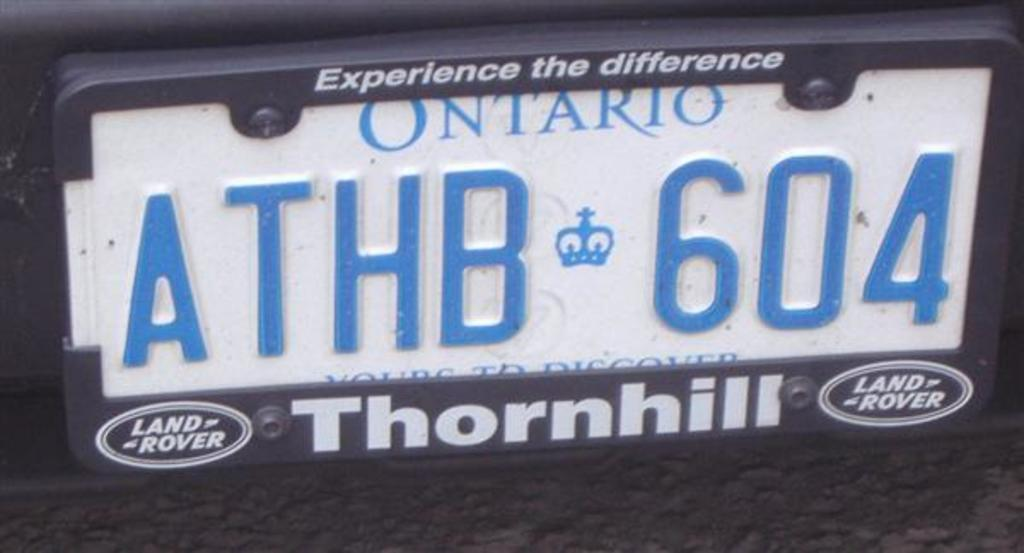What is the main subject in the foreground of the image? There is a number plate of a vehicle in the foreground of the image. What text can be seen on the number plate? The number plate has the text 'A THB 604' on it. How many chairs are placed around the quiet yak in the image? There are no chairs or yaks present in the image; it only features a number plate of a vehicle. 